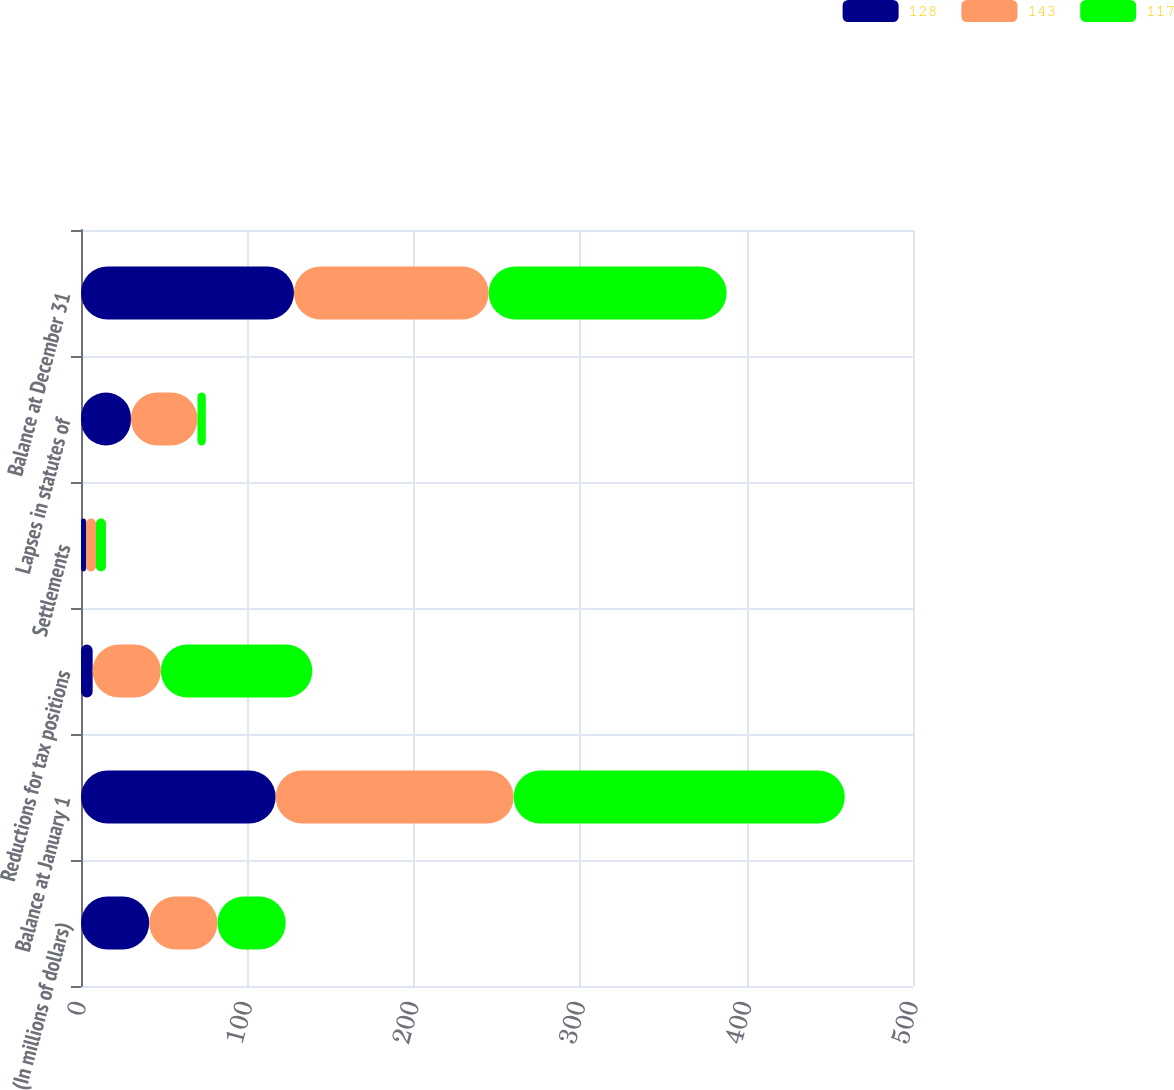Convert chart to OTSL. <chart><loc_0><loc_0><loc_500><loc_500><stacked_bar_chart><ecel><fcel>(In millions of dollars)<fcel>Balance at January 1<fcel>Reductions for tax positions<fcel>Settlements<fcel>Lapses in statutes of<fcel>Balance at December 31<nl><fcel>128<fcel>41<fcel>117<fcel>7<fcel>3<fcel>30<fcel>128<nl><fcel>143<fcel>41<fcel>143<fcel>41<fcel>6<fcel>40<fcel>117<nl><fcel>117<fcel>41<fcel>199<fcel>91<fcel>6<fcel>5<fcel>143<nl></chart> 